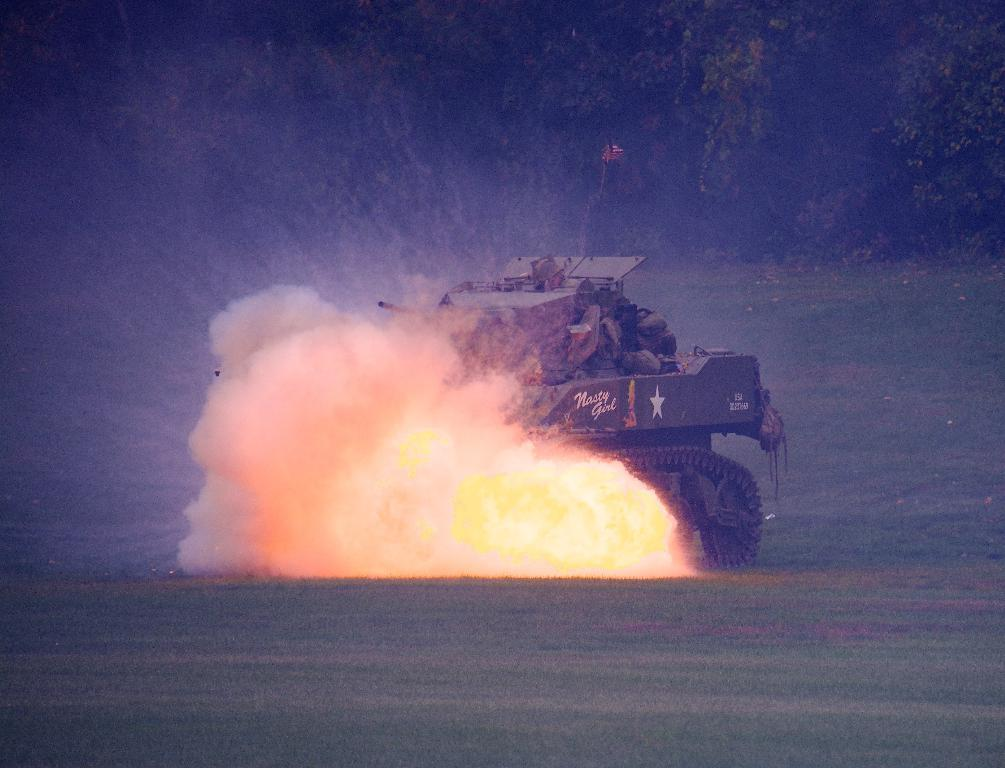What is located on the ground in the image? There is a vehicle on the ground in the image. What is the source of the fire visible in the image? The facts provided do not specify the source of the fire. What can be seen in the background of the image? There are trees in the background of the image. What type of pencil can be seen in the image? There is no pencil present in the image. What kind of joke is being told by the zebra in the image? There is no zebra present in the image, and therefore no joke can be observed. 